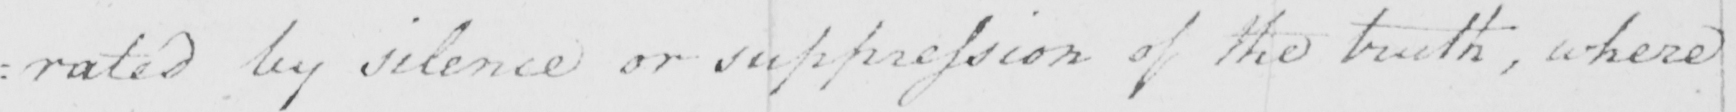What is written in this line of handwriting? : rated by silence or suppression of the truth , where 